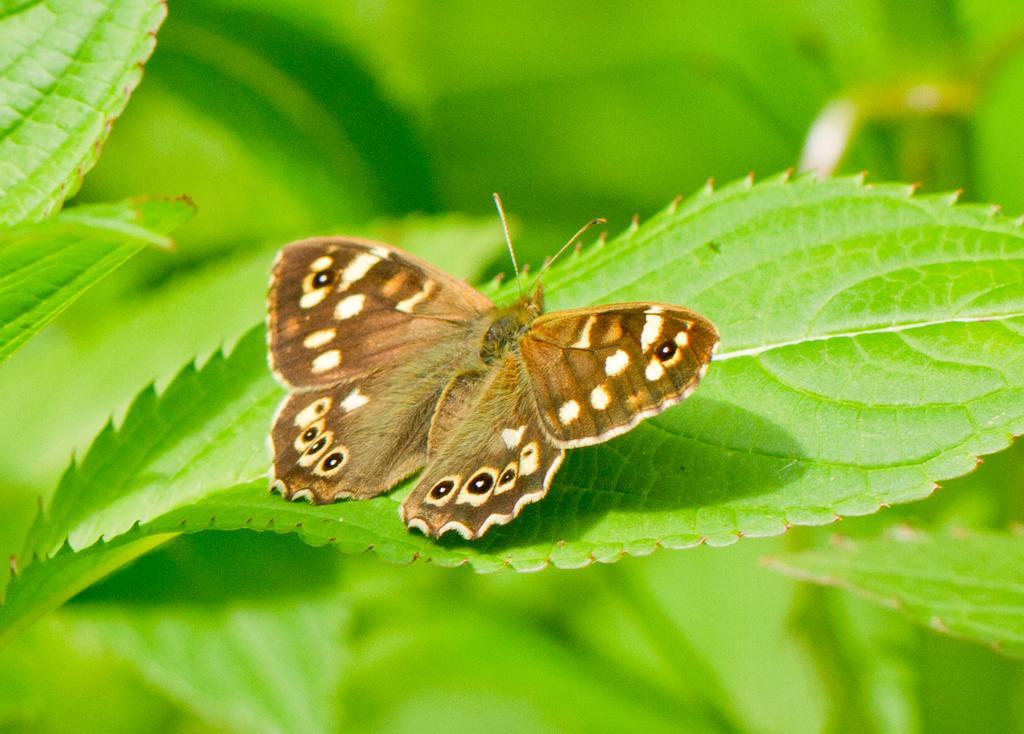How would you summarize this image in a sentence or two? In this picture we can see a brown butterfly on a green leaf. Background is blurry. 